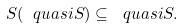Convert formula to latex. <formula><loc_0><loc_0><loc_500><loc_500>S ( \ q u a s i { S } ) \subseteq \ q u a s i { S } .</formula> 